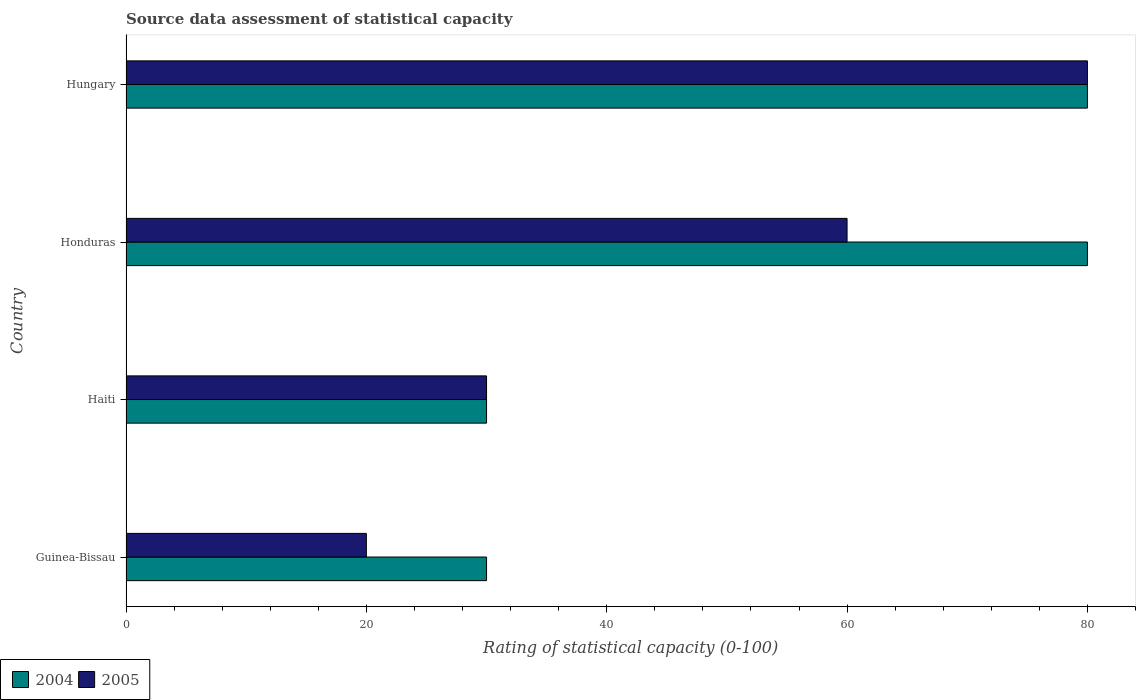How many different coloured bars are there?
Offer a very short reply. 2. Are the number of bars per tick equal to the number of legend labels?
Your answer should be compact. Yes. What is the label of the 1st group of bars from the top?
Provide a succinct answer. Hungary. In how many cases, is the number of bars for a given country not equal to the number of legend labels?
Offer a very short reply. 0. What is the rating of statistical capacity in 2004 in Honduras?
Offer a terse response. 80. In which country was the rating of statistical capacity in 2004 maximum?
Keep it short and to the point. Honduras. In which country was the rating of statistical capacity in 2005 minimum?
Offer a very short reply. Guinea-Bissau. What is the total rating of statistical capacity in 2005 in the graph?
Your response must be concise. 190. What is the difference between the rating of statistical capacity in 2004 in Guinea-Bissau and that in Hungary?
Ensure brevity in your answer.  -50. What is the difference between the rating of statistical capacity in 2005 in Guinea-Bissau and the rating of statistical capacity in 2004 in Hungary?
Your answer should be compact. -60. What is the difference between the rating of statistical capacity in 2005 and rating of statistical capacity in 2004 in Haiti?
Your response must be concise. 0. In how many countries, is the rating of statistical capacity in 2005 greater than 28 ?
Provide a succinct answer. 3. What is the ratio of the rating of statistical capacity in 2005 in Honduras to that in Hungary?
Your answer should be compact. 0.75. What is the difference between the highest and the lowest rating of statistical capacity in 2004?
Offer a terse response. 50. How many bars are there?
Provide a succinct answer. 8. How many countries are there in the graph?
Your response must be concise. 4. How many legend labels are there?
Make the answer very short. 2. How are the legend labels stacked?
Provide a short and direct response. Horizontal. What is the title of the graph?
Ensure brevity in your answer.  Source data assessment of statistical capacity. What is the label or title of the X-axis?
Provide a short and direct response. Rating of statistical capacity (0-100). What is the Rating of statistical capacity (0-100) in 2004 in Guinea-Bissau?
Provide a short and direct response. 30. What is the Rating of statistical capacity (0-100) of 2005 in Guinea-Bissau?
Your answer should be very brief. 20. What is the Rating of statistical capacity (0-100) of 2005 in Haiti?
Your response must be concise. 30. What is the Rating of statistical capacity (0-100) in 2004 in Honduras?
Your response must be concise. 80. What is the Rating of statistical capacity (0-100) of 2005 in Honduras?
Your response must be concise. 60. Across all countries, what is the maximum Rating of statistical capacity (0-100) of 2004?
Keep it short and to the point. 80. Across all countries, what is the maximum Rating of statistical capacity (0-100) in 2005?
Ensure brevity in your answer.  80. Across all countries, what is the minimum Rating of statistical capacity (0-100) in 2004?
Provide a succinct answer. 30. Across all countries, what is the minimum Rating of statistical capacity (0-100) of 2005?
Your answer should be compact. 20. What is the total Rating of statistical capacity (0-100) of 2004 in the graph?
Offer a very short reply. 220. What is the total Rating of statistical capacity (0-100) in 2005 in the graph?
Keep it short and to the point. 190. What is the difference between the Rating of statistical capacity (0-100) of 2004 in Guinea-Bissau and that in Haiti?
Make the answer very short. 0. What is the difference between the Rating of statistical capacity (0-100) in 2005 in Guinea-Bissau and that in Haiti?
Give a very brief answer. -10. What is the difference between the Rating of statistical capacity (0-100) in 2005 in Guinea-Bissau and that in Hungary?
Your answer should be very brief. -60. What is the difference between the Rating of statistical capacity (0-100) in 2005 in Haiti and that in Honduras?
Offer a very short reply. -30. What is the difference between the Rating of statistical capacity (0-100) of 2004 in Haiti and that in Hungary?
Your answer should be very brief. -50. What is the difference between the Rating of statistical capacity (0-100) in 2004 in Honduras and that in Hungary?
Your answer should be very brief. 0. What is the difference between the Rating of statistical capacity (0-100) in 2004 in Guinea-Bissau and the Rating of statistical capacity (0-100) in 2005 in Haiti?
Your response must be concise. 0. What is the difference between the Rating of statistical capacity (0-100) of 2004 in Guinea-Bissau and the Rating of statistical capacity (0-100) of 2005 in Honduras?
Your answer should be very brief. -30. What is the difference between the Rating of statistical capacity (0-100) of 2004 in Guinea-Bissau and the Rating of statistical capacity (0-100) of 2005 in Hungary?
Provide a short and direct response. -50. What is the average Rating of statistical capacity (0-100) of 2005 per country?
Offer a very short reply. 47.5. What is the difference between the Rating of statistical capacity (0-100) in 2004 and Rating of statistical capacity (0-100) in 2005 in Honduras?
Keep it short and to the point. 20. What is the difference between the Rating of statistical capacity (0-100) in 2004 and Rating of statistical capacity (0-100) in 2005 in Hungary?
Offer a terse response. 0. What is the ratio of the Rating of statistical capacity (0-100) in 2004 in Guinea-Bissau to that in Haiti?
Provide a short and direct response. 1. What is the ratio of the Rating of statistical capacity (0-100) of 2005 in Guinea-Bissau to that in Haiti?
Provide a short and direct response. 0.67. What is the ratio of the Rating of statistical capacity (0-100) in 2004 in Guinea-Bissau to that in Honduras?
Your answer should be very brief. 0.38. What is the ratio of the Rating of statistical capacity (0-100) in 2005 in Haiti to that in Honduras?
Offer a very short reply. 0.5. What is the ratio of the Rating of statistical capacity (0-100) in 2004 in Haiti to that in Hungary?
Your answer should be compact. 0.38. What is the ratio of the Rating of statistical capacity (0-100) in 2004 in Honduras to that in Hungary?
Provide a succinct answer. 1. What is the difference between the highest and the second highest Rating of statistical capacity (0-100) in 2005?
Your response must be concise. 20. What is the difference between the highest and the lowest Rating of statistical capacity (0-100) of 2004?
Make the answer very short. 50. What is the difference between the highest and the lowest Rating of statistical capacity (0-100) in 2005?
Give a very brief answer. 60. 